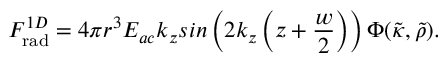Convert formula to latex. <formula><loc_0><loc_0><loc_500><loc_500>F _ { r a d } ^ { 1 D } = 4 \pi r ^ { 3 } E _ { a c } k _ { z } \sin \left ( 2 k _ { z } \left ( z + \frac { w } { 2 } \right ) \right ) \Phi ( \tilde { \kappa } , \tilde { \rho } ) .</formula> 